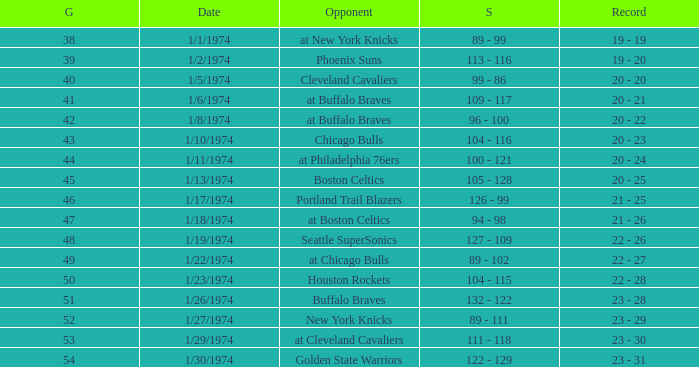What opponent played on 1/13/1974? Boston Celtics. 